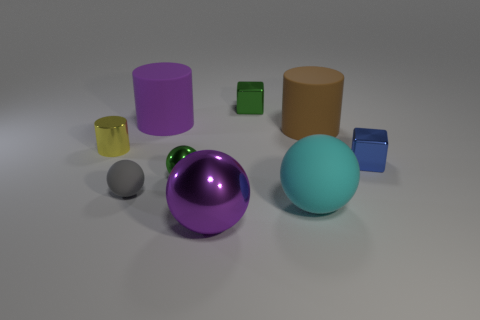How many other things are made of the same material as the brown thing?
Offer a terse response. 3. There is a cylinder that is both in front of the large purple matte thing and on the left side of the large brown cylinder; how big is it?
Offer a very short reply. Small. There is a small green metal object to the right of the shiny sphere that is behind the large matte ball; what is its shape?
Provide a short and direct response. Cube. Are there the same number of big things that are left of the small green metallic sphere and tiny purple shiny blocks?
Keep it short and to the point. No. There is a small metal ball; does it have the same color as the cube that is on the left side of the brown object?
Make the answer very short. Yes. The big rubber thing that is both to the left of the brown matte cylinder and in front of the purple cylinder is what color?
Make the answer very short. Cyan. There is a block behind the small yellow metal cylinder; how many large cyan matte balls are right of it?
Offer a terse response. 1. Are there any other large rubber things of the same shape as the big cyan thing?
Make the answer very short. No. There is a small green metallic object behind the tiny cylinder; is it the same shape as the green metal thing that is in front of the brown cylinder?
Keep it short and to the point. No. What number of things are either big blue cubes or yellow metallic things?
Ensure brevity in your answer.  1. 